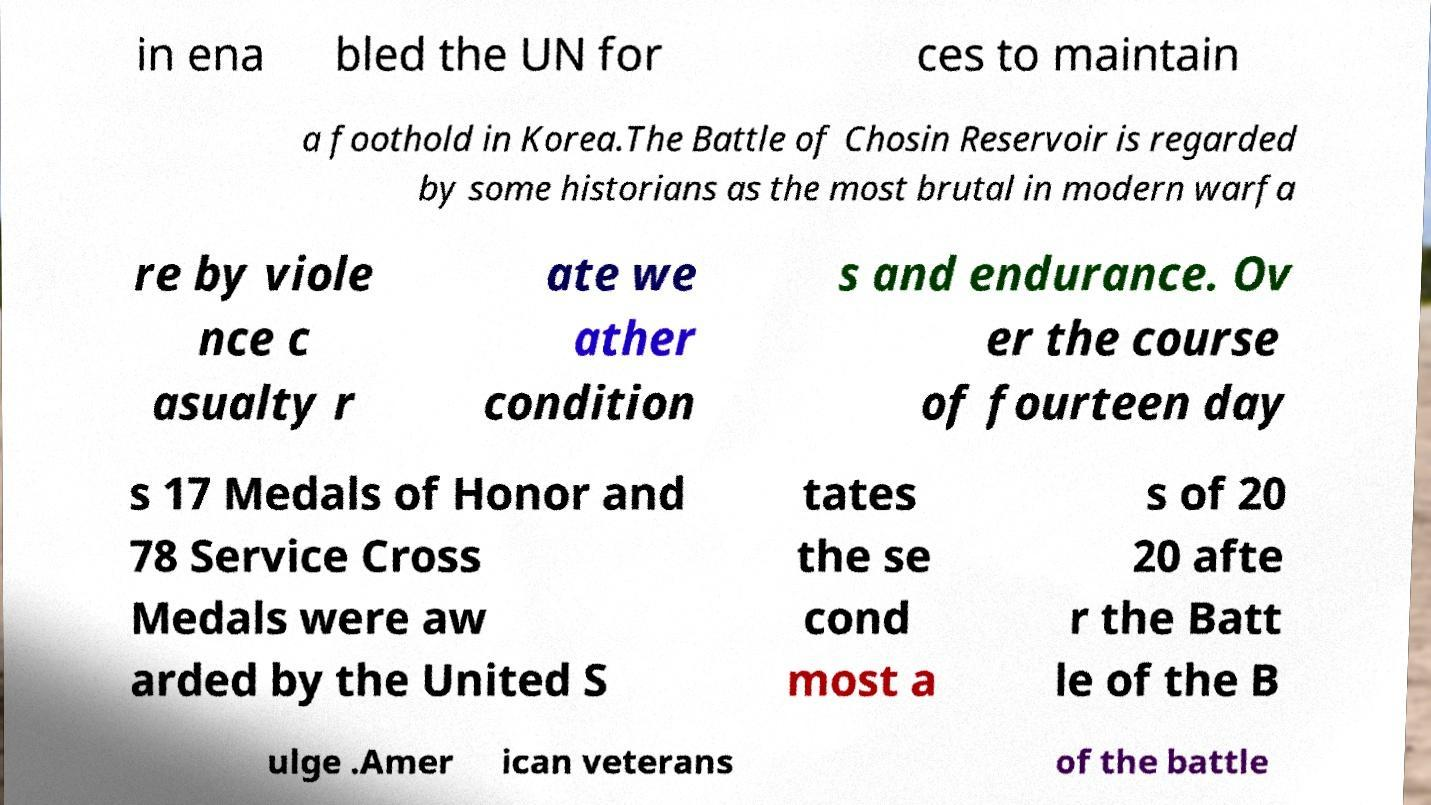Please read and relay the text visible in this image. What does it say? in ena bled the UN for ces to maintain a foothold in Korea.The Battle of Chosin Reservoir is regarded by some historians as the most brutal in modern warfa re by viole nce c asualty r ate we ather condition s and endurance. Ov er the course of fourteen day s 17 Medals of Honor and 78 Service Cross Medals were aw arded by the United S tates the se cond most a s of 20 20 afte r the Batt le of the B ulge .Amer ican veterans of the battle 